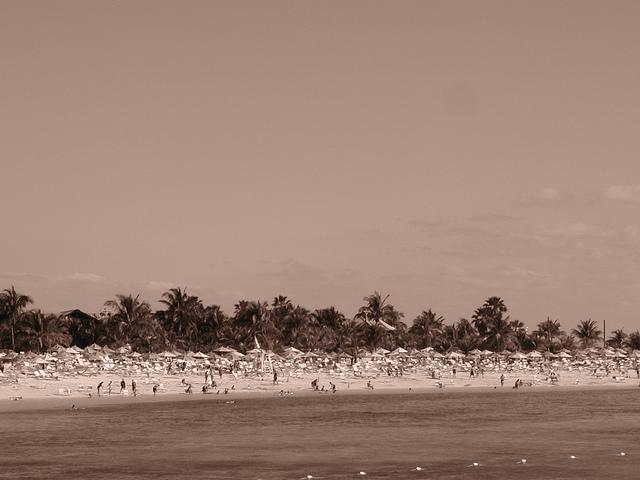Does this scene take place in the summer?
Be succinct. Yes. Are there people on the beach?
Keep it brief. Yes. Where is the picture taken?
Be succinct. Beach. When was this picture taken?
Concise answer only. Daytime. Is it windy?
Be succinct. Yes. Is the water calm?
Write a very short answer. Yes. What season is this?
Keep it brief. Summer. What is the crowd looking at?
Write a very short answer. Water. Is this like a seaside resort?
Quick response, please. Yes. 